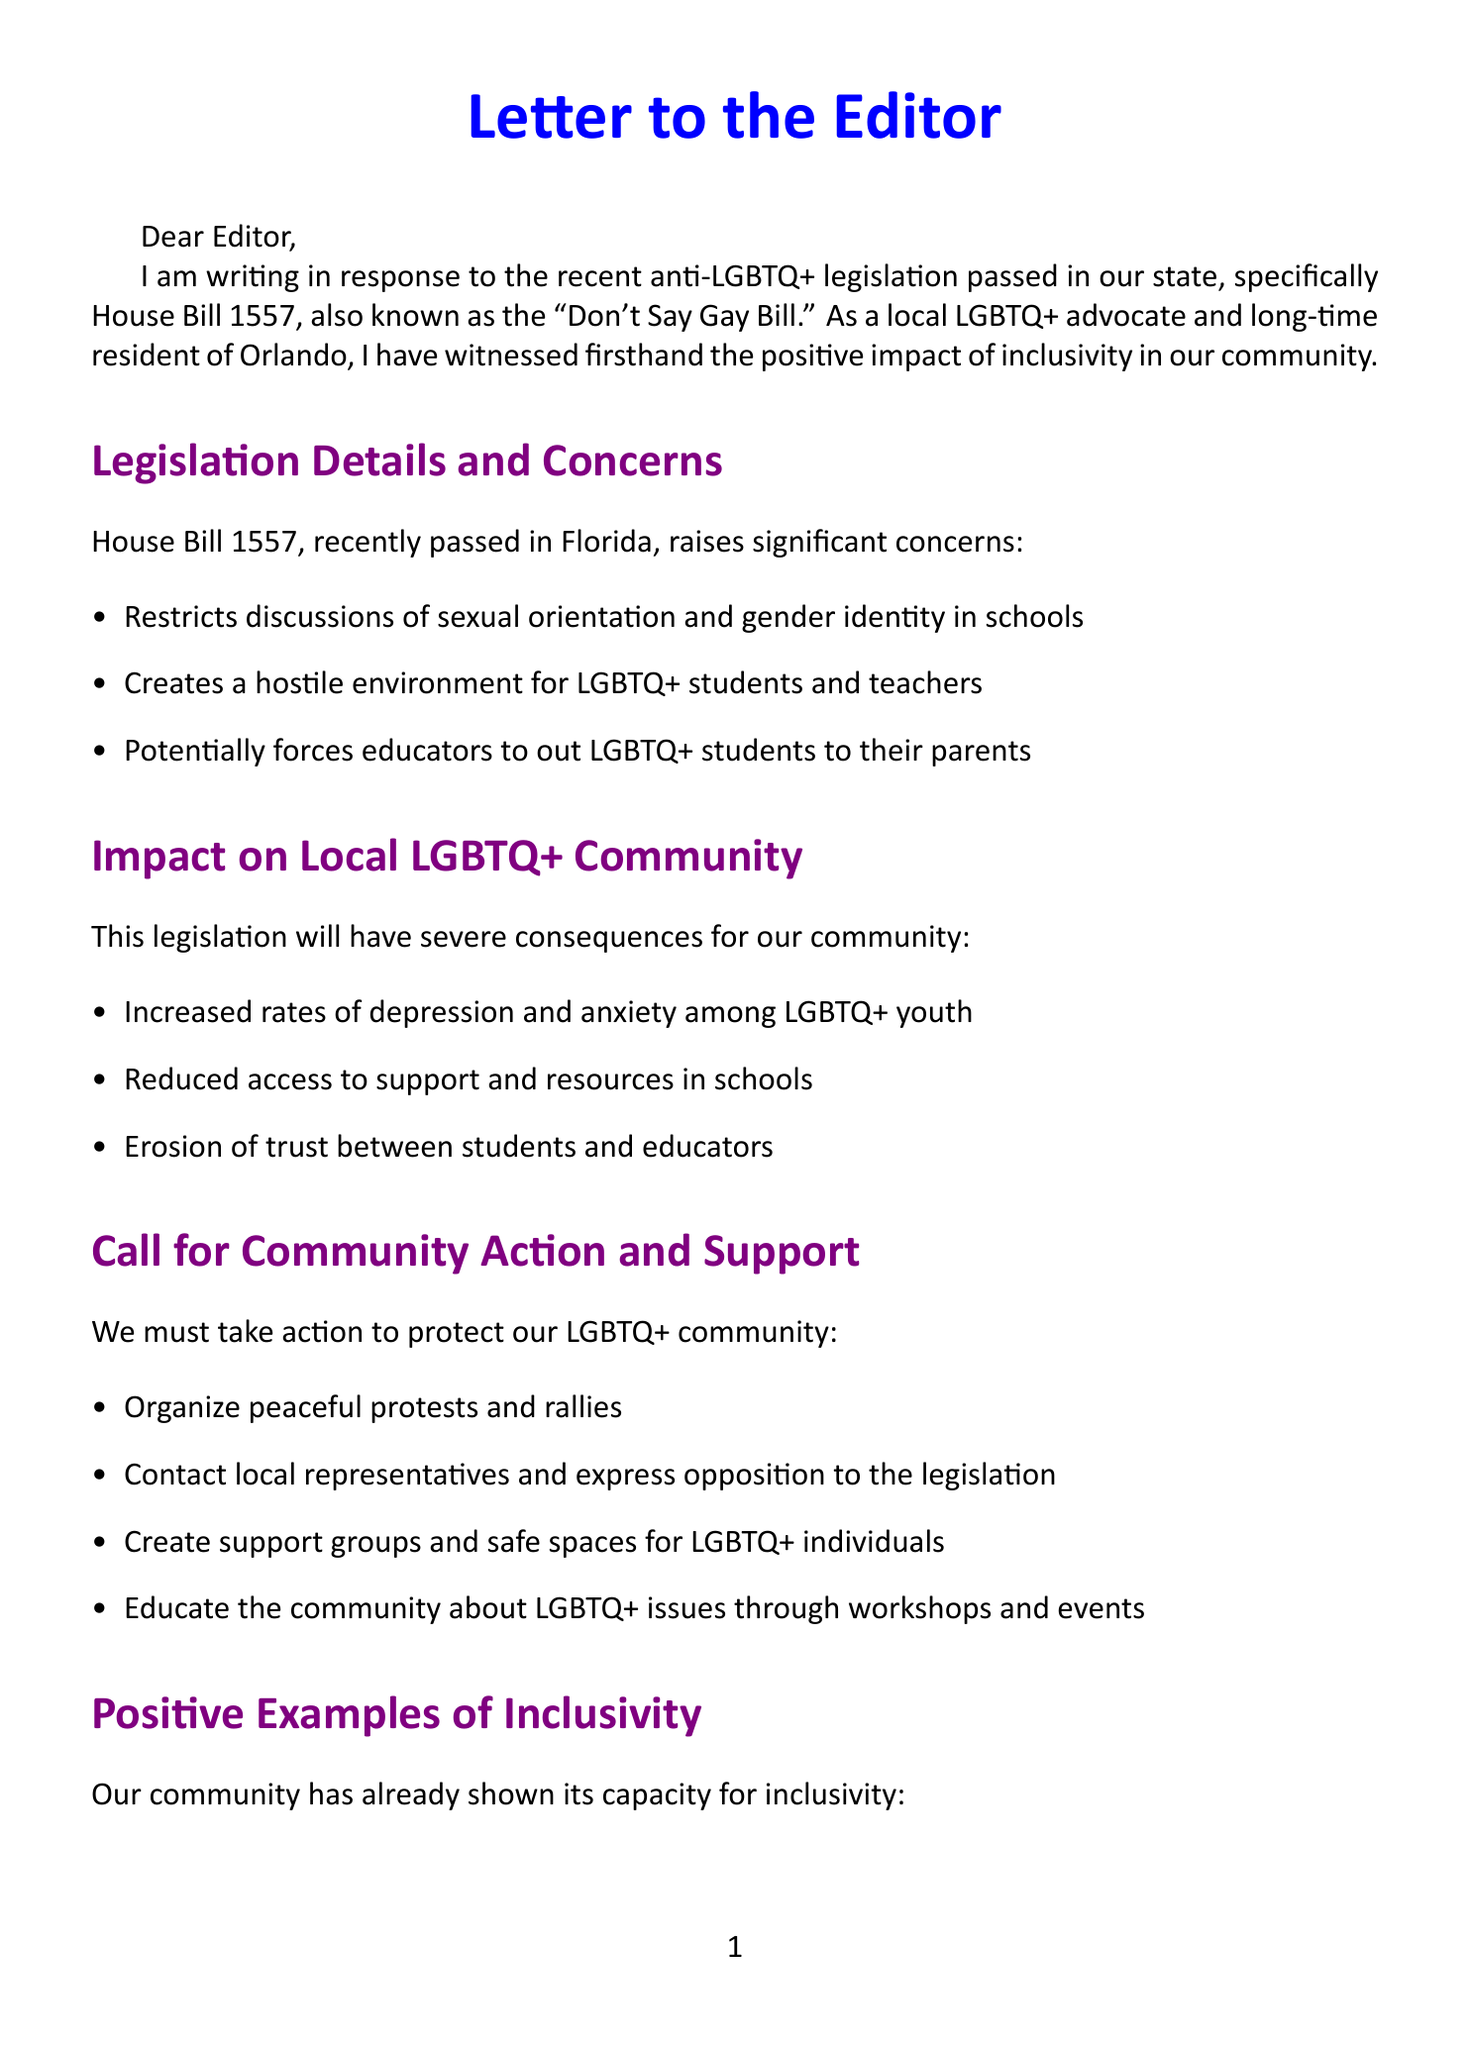What is the name of the legislation discussed? The letter discusses House Bill 1557, which is also known as the "Don't Say Gay Bill."
Answer: House Bill 1557 What is one main concern regarding the legislation? The letter lists several main concerns, one of which is the restriction of discussions of sexual orientation and gender identity in schools.
Answer: Restricts discussions of sexual orientation and gender identity in schools How many local resources for support are mentioned? The document lists three local resources, including a support hotline and legal aid providers.
Answer: Three Who is acknowledged for supporting the LGBTQ+ community? The letter mentions Taylor Swift as a public figure who has shown support for LGBTQ+ rights.
Answer: Taylor Swift What is one suggested action for community support? One suggested action is to organize peaceful protests and rallies to oppose the legislation.
Answer: Organize peaceful protests and rallies What organization is mentioned that provides support to LGBTQ+ individuals? The letter includes PFLAG Central Florida as a community organization that offers resources and support.
Answer: PFLAG Central Florida What city is referenced in the letter? The letter mentions the city of Orlando where the author is a resident and advocate.
Answer: Orlando What is one potential consequence of the legislation mentioned in the document? Among the potential consequences listed, one is the increased rates of depression and anxiety among LGBTQ+ youth.
Answer: Increased rates of depression and anxiety among LGBTQ+ youth 